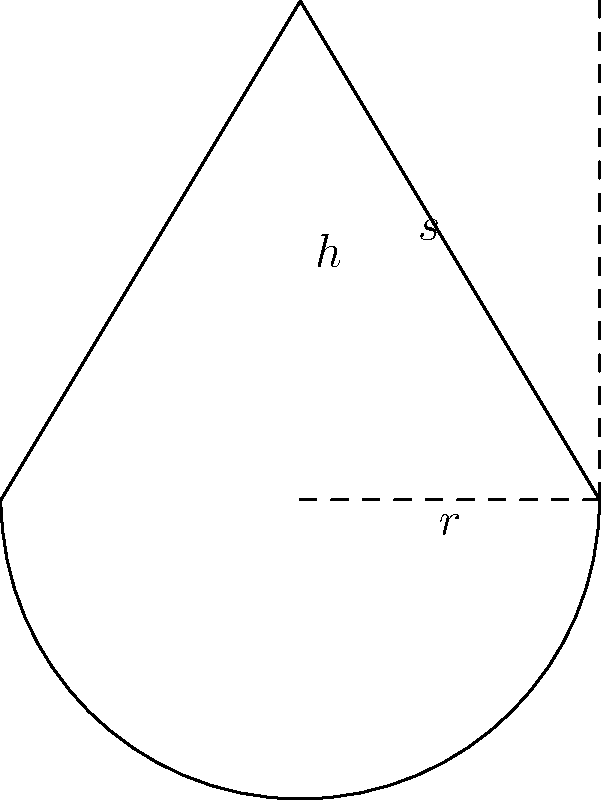A conical food package has a radius of 3 cm and a height of 5 cm. Calculate the total surface area of the package, including the circular base. Use $\pi = 3.14$ for your calculations. How might the surface area affect the nutrient content of the packaged food? To calculate the total surface area of the conical food package, we need to find the area of the circular base and the lateral surface area of the cone, then sum them up.

Step 1: Calculate the area of the circular base
$A_{base} = \pi r^2 = 3.14 \times 3^2 = 28.26$ cm²

Step 2: Calculate the slant height of the cone using the Pythagorean theorem
$s = \sqrt{r^2 + h^2} = \sqrt{3^2 + 5^2} = \sqrt{34} \approx 5.83$ cm

Step 3: Calculate the lateral surface area of the cone
$A_{lateral} = \pi r s = 3.14 \times 3 \times 5.83 = 54.91$ cm²

Step 4: Calculate the total surface area by adding the base area and lateral area
$A_{total} = A_{base} + A_{lateral} = 28.26 + 54.91 = 83.17$ cm²

The surface area might affect the nutrient content of the packaged food by influencing the amount of contact between the food and the packaging material. A larger surface area could potentially lead to more interactions between the food and the package, which might impact nutrient retention or degradation over time.
Answer: 83.17 cm² 